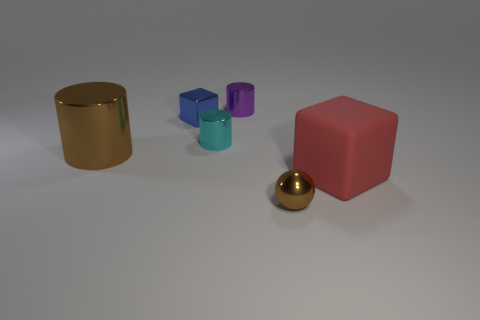How many other things are made of the same material as the purple cylinder?
Give a very brief answer. 4. The small shiny thing that is left of the tiny cyan metal object that is to the right of the blue metal object is what shape?
Ensure brevity in your answer.  Cube. What is the size of the brown thing behind the big rubber object?
Your answer should be compact. Large. Is the purple cylinder made of the same material as the red thing?
Your response must be concise. No. There is a blue thing that is the same material as the small brown object; what shape is it?
Your answer should be very brief. Cube. Is there anything else that has the same color as the large cylinder?
Provide a succinct answer. Yes. The cylinder that is behind the tiny block is what color?
Provide a short and direct response. Purple. Do the big object left of the tiny cyan shiny object and the tiny metal ball have the same color?
Make the answer very short. Yes. There is a large red thing that is the same shape as the tiny blue metal object; what is it made of?
Make the answer very short. Rubber. How many things have the same size as the purple cylinder?
Ensure brevity in your answer.  3. 